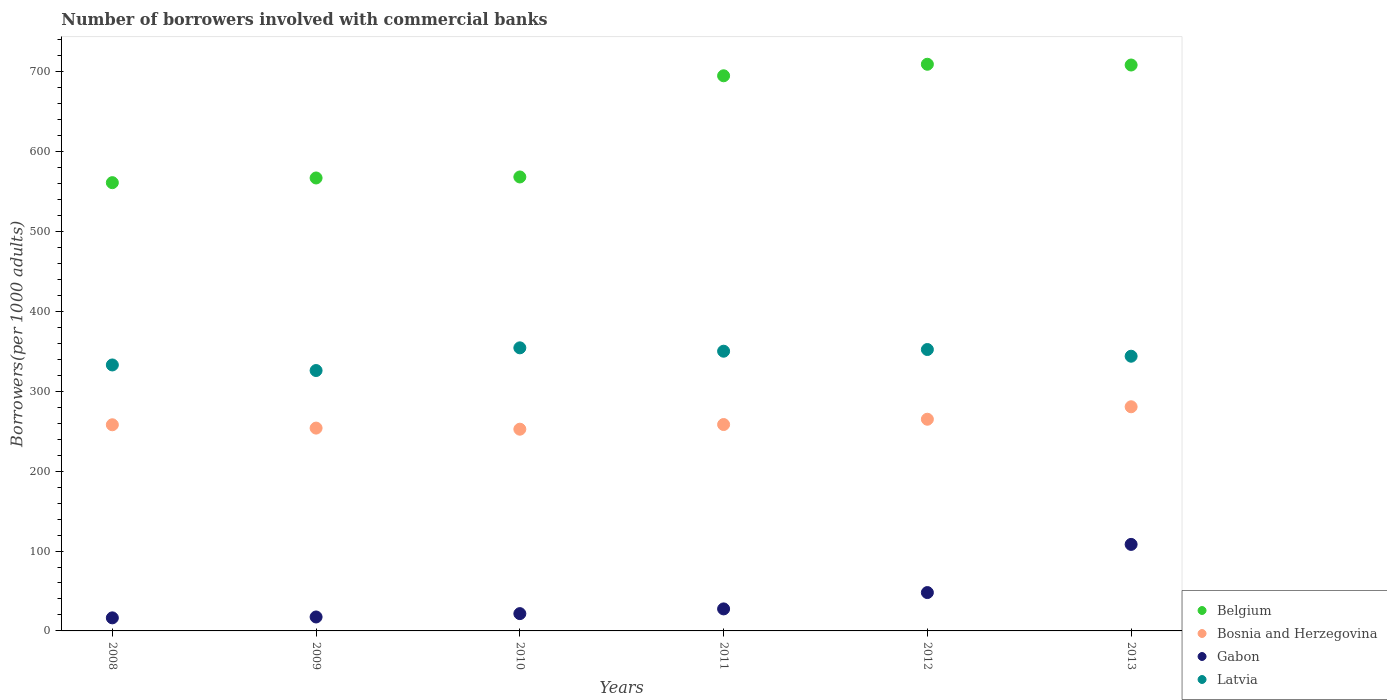What is the number of borrowers involved with commercial banks in Bosnia and Herzegovina in 2011?
Your response must be concise. 258.35. Across all years, what is the maximum number of borrowers involved with commercial banks in Bosnia and Herzegovina?
Make the answer very short. 280.59. Across all years, what is the minimum number of borrowers involved with commercial banks in Belgium?
Your answer should be very brief. 561.13. What is the total number of borrowers involved with commercial banks in Belgium in the graph?
Keep it short and to the point. 3809.04. What is the difference between the number of borrowers involved with commercial banks in Belgium in 2009 and that in 2011?
Your answer should be compact. -127.92. What is the difference between the number of borrowers involved with commercial banks in Bosnia and Herzegovina in 2008 and the number of borrowers involved with commercial banks in Latvia in 2009?
Keep it short and to the point. -67.89. What is the average number of borrowers involved with commercial banks in Latvia per year?
Keep it short and to the point. 343.25. In the year 2009, what is the difference between the number of borrowers involved with commercial banks in Bosnia and Herzegovina and number of borrowers involved with commercial banks in Belgium?
Your answer should be compact. -313.11. In how many years, is the number of borrowers involved with commercial banks in Latvia greater than 220?
Ensure brevity in your answer.  6. What is the ratio of the number of borrowers involved with commercial banks in Bosnia and Herzegovina in 2012 to that in 2013?
Ensure brevity in your answer.  0.94. Is the number of borrowers involved with commercial banks in Gabon in 2011 less than that in 2013?
Your answer should be compact. Yes. What is the difference between the highest and the second highest number of borrowers involved with commercial banks in Belgium?
Keep it short and to the point. 0.95. What is the difference between the highest and the lowest number of borrowers involved with commercial banks in Belgium?
Ensure brevity in your answer.  148.22. Is it the case that in every year, the sum of the number of borrowers involved with commercial banks in Gabon and number of borrowers involved with commercial banks in Latvia  is greater than the sum of number of borrowers involved with commercial banks in Bosnia and Herzegovina and number of borrowers involved with commercial banks in Belgium?
Your response must be concise. No. Is it the case that in every year, the sum of the number of borrowers involved with commercial banks in Belgium and number of borrowers involved with commercial banks in Gabon  is greater than the number of borrowers involved with commercial banks in Latvia?
Provide a succinct answer. Yes. Is the number of borrowers involved with commercial banks in Bosnia and Herzegovina strictly less than the number of borrowers involved with commercial banks in Gabon over the years?
Your response must be concise. No. Where does the legend appear in the graph?
Provide a succinct answer. Bottom right. How are the legend labels stacked?
Ensure brevity in your answer.  Vertical. What is the title of the graph?
Provide a short and direct response. Number of borrowers involved with commercial banks. Does "Europe(all income levels)" appear as one of the legend labels in the graph?
Offer a very short reply. No. What is the label or title of the X-axis?
Ensure brevity in your answer.  Years. What is the label or title of the Y-axis?
Offer a terse response. Borrowers(per 1000 adults). What is the Borrowers(per 1000 adults) in Belgium in 2008?
Make the answer very short. 561.13. What is the Borrowers(per 1000 adults) of Bosnia and Herzegovina in 2008?
Make the answer very short. 258.06. What is the Borrowers(per 1000 adults) in Gabon in 2008?
Your response must be concise. 16.35. What is the Borrowers(per 1000 adults) of Latvia in 2008?
Your response must be concise. 332.93. What is the Borrowers(per 1000 adults) in Belgium in 2009?
Offer a very short reply. 567. What is the Borrowers(per 1000 adults) of Bosnia and Herzegovina in 2009?
Your answer should be very brief. 253.89. What is the Borrowers(per 1000 adults) in Gabon in 2009?
Provide a succinct answer. 17.46. What is the Borrowers(per 1000 adults) in Latvia in 2009?
Your answer should be very brief. 325.95. What is the Borrowers(per 1000 adults) in Belgium in 2010?
Make the answer very short. 568.25. What is the Borrowers(per 1000 adults) of Bosnia and Herzegovina in 2010?
Ensure brevity in your answer.  252.52. What is the Borrowers(per 1000 adults) of Gabon in 2010?
Keep it short and to the point. 21.66. What is the Borrowers(per 1000 adults) in Latvia in 2010?
Offer a terse response. 354.36. What is the Borrowers(per 1000 adults) of Belgium in 2011?
Ensure brevity in your answer.  694.92. What is the Borrowers(per 1000 adults) in Bosnia and Herzegovina in 2011?
Offer a very short reply. 258.35. What is the Borrowers(per 1000 adults) in Gabon in 2011?
Make the answer very short. 27.56. What is the Borrowers(per 1000 adults) in Latvia in 2011?
Your response must be concise. 350.14. What is the Borrowers(per 1000 adults) in Belgium in 2012?
Give a very brief answer. 709.35. What is the Borrowers(per 1000 adults) of Bosnia and Herzegovina in 2012?
Ensure brevity in your answer.  264.98. What is the Borrowers(per 1000 adults) in Gabon in 2012?
Your response must be concise. 48.02. What is the Borrowers(per 1000 adults) of Latvia in 2012?
Keep it short and to the point. 352.26. What is the Borrowers(per 1000 adults) of Belgium in 2013?
Your answer should be very brief. 708.39. What is the Borrowers(per 1000 adults) in Bosnia and Herzegovina in 2013?
Give a very brief answer. 280.59. What is the Borrowers(per 1000 adults) in Gabon in 2013?
Provide a succinct answer. 108.3. What is the Borrowers(per 1000 adults) of Latvia in 2013?
Your answer should be compact. 343.87. Across all years, what is the maximum Borrowers(per 1000 adults) in Belgium?
Ensure brevity in your answer.  709.35. Across all years, what is the maximum Borrowers(per 1000 adults) in Bosnia and Herzegovina?
Offer a very short reply. 280.59. Across all years, what is the maximum Borrowers(per 1000 adults) in Gabon?
Offer a very short reply. 108.3. Across all years, what is the maximum Borrowers(per 1000 adults) of Latvia?
Keep it short and to the point. 354.36. Across all years, what is the minimum Borrowers(per 1000 adults) in Belgium?
Offer a very short reply. 561.13. Across all years, what is the minimum Borrowers(per 1000 adults) of Bosnia and Herzegovina?
Your answer should be compact. 252.52. Across all years, what is the minimum Borrowers(per 1000 adults) of Gabon?
Provide a short and direct response. 16.35. Across all years, what is the minimum Borrowers(per 1000 adults) of Latvia?
Keep it short and to the point. 325.95. What is the total Borrowers(per 1000 adults) in Belgium in the graph?
Give a very brief answer. 3809.04. What is the total Borrowers(per 1000 adults) of Bosnia and Herzegovina in the graph?
Your answer should be compact. 1568.4. What is the total Borrowers(per 1000 adults) in Gabon in the graph?
Keep it short and to the point. 239.34. What is the total Borrowers(per 1000 adults) in Latvia in the graph?
Make the answer very short. 2059.51. What is the difference between the Borrowers(per 1000 adults) of Belgium in 2008 and that in 2009?
Provide a short and direct response. -5.87. What is the difference between the Borrowers(per 1000 adults) in Bosnia and Herzegovina in 2008 and that in 2009?
Your answer should be very brief. 4.17. What is the difference between the Borrowers(per 1000 adults) of Gabon in 2008 and that in 2009?
Your answer should be compact. -1.11. What is the difference between the Borrowers(per 1000 adults) in Latvia in 2008 and that in 2009?
Provide a succinct answer. 6.98. What is the difference between the Borrowers(per 1000 adults) in Belgium in 2008 and that in 2010?
Your answer should be compact. -7.13. What is the difference between the Borrowers(per 1000 adults) of Bosnia and Herzegovina in 2008 and that in 2010?
Offer a very short reply. 5.55. What is the difference between the Borrowers(per 1000 adults) in Gabon in 2008 and that in 2010?
Offer a very short reply. -5.3. What is the difference between the Borrowers(per 1000 adults) in Latvia in 2008 and that in 2010?
Provide a short and direct response. -21.43. What is the difference between the Borrowers(per 1000 adults) of Belgium in 2008 and that in 2011?
Make the answer very short. -133.79. What is the difference between the Borrowers(per 1000 adults) in Bosnia and Herzegovina in 2008 and that in 2011?
Your answer should be very brief. -0.29. What is the difference between the Borrowers(per 1000 adults) of Gabon in 2008 and that in 2011?
Your answer should be compact. -11.21. What is the difference between the Borrowers(per 1000 adults) in Latvia in 2008 and that in 2011?
Make the answer very short. -17.21. What is the difference between the Borrowers(per 1000 adults) in Belgium in 2008 and that in 2012?
Your answer should be very brief. -148.22. What is the difference between the Borrowers(per 1000 adults) in Bosnia and Herzegovina in 2008 and that in 2012?
Your response must be concise. -6.92. What is the difference between the Borrowers(per 1000 adults) in Gabon in 2008 and that in 2012?
Offer a terse response. -31.67. What is the difference between the Borrowers(per 1000 adults) in Latvia in 2008 and that in 2012?
Offer a terse response. -19.32. What is the difference between the Borrowers(per 1000 adults) of Belgium in 2008 and that in 2013?
Provide a succinct answer. -147.27. What is the difference between the Borrowers(per 1000 adults) of Bosnia and Herzegovina in 2008 and that in 2013?
Your answer should be compact. -22.52. What is the difference between the Borrowers(per 1000 adults) of Gabon in 2008 and that in 2013?
Your answer should be very brief. -91.95. What is the difference between the Borrowers(per 1000 adults) of Latvia in 2008 and that in 2013?
Give a very brief answer. -10.93. What is the difference between the Borrowers(per 1000 adults) in Belgium in 2009 and that in 2010?
Keep it short and to the point. -1.25. What is the difference between the Borrowers(per 1000 adults) of Bosnia and Herzegovina in 2009 and that in 2010?
Your answer should be very brief. 1.38. What is the difference between the Borrowers(per 1000 adults) of Gabon in 2009 and that in 2010?
Provide a succinct answer. -4.2. What is the difference between the Borrowers(per 1000 adults) of Latvia in 2009 and that in 2010?
Offer a very short reply. -28.41. What is the difference between the Borrowers(per 1000 adults) in Belgium in 2009 and that in 2011?
Provide a short and direct response. -127.92. What is the difference between the Borrowers(per 1000 adults) in Bosnia and Herzegovina in 2009 and that in 2011?
Your answer should be very brief. -4.46. What is the difference between the Borrowers(per 1000 adults) of Gabon in 2009 and that in 2011?
Your answer should be very brief. -10.1. What is the difference between the Borrowers(per 1000 adults) of Latvia in 2009 and that in 2011?
Provide a short and direct response. -24.19. What is the difference between the Borrowers(per 1000 adults) of Belgium in 2009 and that in 2012?
Your answer should be very brief. -142.35. What is the difference between the Borrowers(per 1000 adults) of Bosnia and Herzegovina in 2009 and that in 2012?
Ensure brevity in your answer.  -11.09. What is the difference between the Borrowers(per 1000 adults) in Gabon in 2009 and that in 2012?
Ensure brevity in your answer.  -30.56. What is the difference between the Borrowers(per 1000 adults) in Latvia in 2009 and that in 2012?
Provide a short and direct response. -26.3. What is the difference between the Borrowers(per 1000 adults) of Belgium in 2009 and that in 2013?
Your response must be concise. -141.39. What is the difference between the Borrowers(per 1000 adults) in Bosnia and Herzegovina in 2009 and that in 2013?
Ensure brevity in your answer.  -26.69. What is the difference between the Borrowers(per 1000 adults) in Gabon in 2009 and that in 2013?
Your answer should be compact. -90.84. What is the difference between the Borrowers(per 1000 adults) of Latvia in 2009 and that in 2013?
Provide a succinct answer. -17.92. What is the difference between the Borrowers(per 1000 adults) in Belgium in 2010 and that in 2011?
Give a very brief answer. -126.66. What is the difference between the Borrowers(per 1000 adults) in Bosnia and Herzegovina in 2010 and that in 2011?
Make the answer very short. -5.84. What is the difference between the Borrowers(per 1000 adults) of Gabon in 2010 and that in 2011?
Give a very brief answer. -5.9. What is the difference between the Borrowers(per 1000 adults) in Latvia in 2010 and that in 2011?
Your answer should be very brief. 4.22. What is the difference between the Borrowers(per 1000 adults) of Belgium in 2010 and that in 2012?
Your answer should be compact. -141.09. What is the difference between the Borrowers(per 1000 adults) in Bosnia and Herzegovina in 2010 and that in 2012?
Ensure brevity in your answer.  -12.47. What is the difference between the Borrowers(per 1000 adults) of Gabon in 2010 and that in 2012?
Make the answer very short. -26.36. What is the difference between the Borrowers(per 1000 adults) in Latvia in 2010 and that in 2012?
Your response must be concise. 2.11. What is the difference between the Borrowers(per 1000 adults) of Belgium in 2010 and that in 2013?
Provide a short and direct response. -140.14. What is the difference between the Borrowers(per 1000 adults) in Bosnia and Herzegovina in 2010 and that in 2013?
Your answer should be very brief. -28.07. What is the difference between the Borrowers(per 1000 adults) in Gabon in 2010 and that in 2013?
Offer a very short reply. -86.65. What is the difference between the Borrowers(per 1000 adults) in Latvia in 2010 and that in 2013?
Your response must be concise. 10.49. What is the difference between the Borrowers(per 1000 adults) in Belgium in 2011 and that in 2012?
Give a very brief answer. -14.43. What is the difference between the Borrowers(per 1000 adults) of Bosnia and Herzegovina in 2011 and that in 2012?
Offer a terse response. -6.63. What is the difference between the Borrowers(per 1000 adults) in Gabon in 2011 and that in 2012?
Your answer should be compact. -20.46. What is the difference between the Borrowers(per 1000 adults) of Latvia in 2011 and that in 2012?
Your response must be concise. -2.12. What is the difference between the Borrowers(per 1000 adults) in Belgium in 2011 and that in 2013?
Provide a short and direct response. -13.48. What is the difference between the Borrowers(per 1000 adults) in Bosnia and Herzegovina in 2011 and that in 2013?
Your answer should be compact. -22.23. What is the difference between the Borrowers(per 1000 adults) in Gabon in 2011 and that in 2013?
Keep it short and to the point. -80.74. What is the difference between the Borrowers(per 1000 adults) of Latvia in 2011 and that in 2013?
Your answer should be compact. 6.27. What is the difference between the Borrowers(per 1000 adults) of Belgium in 2012 and that in 2013?
Make the answer very short. 0.95. What is the difference between the Borrowers(per 1000 adults) in Bosnia and Herzegovina in 2012 and that in 2013?
Offer a terse response. -15.6. What is the difference between the Borrowers(per 1000 adults) of Gabon in 2012 and that in 2013?
Provide a short and direct response. -60.28. What is the difference between the Borrowers(per 1000 adults) in Latvia in 2012 and that in 2013?
Ensure brevity in your answer.  8.39. What is the difference between the Borrowers(per 1000 adults) in Belgium in 2008 and the Borrowers(per 1000 adults) in Bosnia and Herzegovina in 2009?
Offer a terse response. 307.23. What is the difference between the Borrowers(per 1000 adults) in Belgium in 2008 and the Borrowers(per 1000 adults) in Gabon in 2009?
Your answer should be very brief. 543.67. What is the difference between the Borrowers(per 1000 adults) in Belgium in 2008 and the Borrowers(per 1000 adults) in Latvia in 2009?
Your answer should be very brief. 235.17. What is the difference between the Borrowers(per 1000 adults) of Bosnia and Herzegovina in 2008 and the Borrowers(per 1000 adults) of Gabon in 2009?
Your answer should be very brief. 240.61. What is the difference between the Borrowers(per 1000 adults) of Bosnia and Herzegovina in 2008 and the Borrowers(per 1000 adults) of Latvia in 2009?
Ensure brevity in your answer.  -67.89. What is the difference between the Borrowers(per 1000 adults) of Gabon in 2008 and the Borrowers(per 1000 adults) of Latvia in 2009?
Give a very brief answer. -309.6. What is the difference between the Borrowers(per 1000 adults) of Belgium in 2008 and the Borrowers(per 1000 adults) of Bosnia and Herzegovina in 2010?
Your response must be concise. 308.61. What is the difference between the Borrowers(per 1000 adults) in Belgium in 2008 and the Borrowers(per 1000 adults) in Gabon in 2010?
Ensure brevity in your answer.  539.47. What is the difference between the Borrowers(per 1000 adults) in Belgium in 2008 and the Borrowers(per 1000 adults) in Latvia in 2010?
Give a very brief answer. 206.76. What is the difference between the Borrowers(per 1000 adults) of Bosnia and Herzegovina in 2008 and the Borrowers(per 1000 adults) of Gabon in 2010?
Give a very brief answer. 236.41. What is the difference between the Borrowers(per 1000 adults) of Bosnia and Herzegovina in 2008 and the Borrowers(per 1000 adults) of Latvia in 2010?
Keep it short and to the point. -96.3. What is the difference between the Borrowers(per 1000 adults) in Gabon in 2008 and the Borrowers(per 1000 adults) in Latvia in 2010?
Your response must be concise. -338.01. What is the difference between the Borrowers(per 1000 adults) of Belgium in 2008 and the Borrowers(per 1000 adults) of Bosnia and Herzegovina in 2011?
Give a very brief answer. 302.77. What is the difference between the Borrowers(per 1000 adults) of Belgium in 2008 and the Borrowers(per 1000 adults) of Gabon in 2011?
Offer a very short reply. 533.57. What is the difference between the Borrowers(per 1000 adults) in Belgium in 2008 and the Borrowers(per 1000 adults) in Latvia in 2011?
Ensure brevity in your answer.  210.99. What is the difference between the Borrowers(per 1000 adults) in Bosnia and Herzegovina in 2008 and the Borrowers(per 1000 adults) in Gabon in 2011?
Provide a succinct answer. 230.5. What is the difference between the Borrowers(per 1000 adults) in Bosnia and Herzegovina in 2008 and the Borrowers(per 1000 adults) in Latvia in 2011?
Offer a very short reply. -92.08. What is the difference between the Borrowers(per 1000 adults) in Gabon in 2008 and the Borrowers(per 1000 adults) in Latvia in 2011?
Keep it short and to the point. -333.79. What is the difference between the Borrowers(per 1000 adults) of Belgium in 2008 and the Borrowers(per 1000 adults) of Bosnia and Herzegovina in 2012?
Provide a short and direct response. 296.14. What is the difference between the Borrowers(per 1000 adults) in Belgium in 2008 and the Borrowers(per 1000 adults) in Gabon in 2012?
Offer a very short reply. 513.11. What is the difference between the Borrowers(per 1000 adults) in Belgium in 2008 and the Borrowers(per 1000 adults) in Latvia in 2012?
Give a very brief answer. 208.87. What is the difference between the Borrowers(per 1000 adults) of Bosnia and Herzegovina in 2008 and the Borrowers(per 1000 adults) of Gabon in 2012?
Provide a short and direct response. 210.05. What is the difference between the Borrowers(per 1000 adults) of Bosnia and Herzegovina in 2008 and the Borrowers(per 1000 adults) of Latvia in 2012?
Your answer should be compact. -94.19. What is the difference between the Borrowers(per 1000 adults) of Gabon in 2008 and the Borrowers(per 1000 adults) of Latvia in 2012?
Your response must be concise. -335.9. What is the difference between the Borrowers(per 1000 adults) of Belgium in 2008 and the Borrowers(per 1000 adults) of Bosnia and Herzegovina in 2013?
Your response must be concise. 280.54. What is the difference between the Borrowers(per 1000 adults) in Belgium in 2008 and the Borrowers(per 1000 adults) in Gabon in 2013?
Your answer should be very brief. 452.83. What is the difference between the Borrowers(per 1000 adults) in Belgium in 2008 and the Borrowers(per 1000 adults) in Latvia in 2013?
Your answer should be compact. 217.26. What is the difference between the Borrowers(per 1000 adults) of Bosnia and Herzegovina in 2008 and the Borrowers(per 1000 adults) of Gabon in 2013?
Offer a very short reply. 149.76. What is the difference between the Borrowers(per 1000 adults) of Bosnia and Herzegovina in 2008 and the Borrowers(per 1000 adults) of Latvia in 2013?
Ensure brevity in your answer.  -85.8. What is the difference between the Borrowers(per 1000 adults) of Gabon in 2008 and the Borrowers(per 1000 adults) of Latvia in 2013?
Give a very brief answer. -327.52. What is the difference between the Borrowers(per 1000 adults) of Belgium in 2009 and the Borrowers(per 1000 adults) of Bosnia and Herzegovina in 2010?
Ensure brevity in your answer.  314.48. What is the difference between the Borrowers(per 1000 adults) in Belgium in 2009 and the Borrowers(per 1000 adults) in Gabon in 2010?
Your answer should be very brief. 545.34. What is the difference between the Borrowers(per 1000 adults) in Belgium in 2009 and the Borrowers(per 1000 adults) in Latvia in 2010?
Your answer should be compact. 212.64. What is the difference between the Borrowers(per 1000 adults) in Bosnia and Herzegovina in 2009 and the Borrowers(per 1000 adults) in Gabon in 2010?
Provide a succinct answer. 232.24. What is the difference between the Borrowers(per 1000 adults) of Bosnia and Herzegovina in 2009 and the Borrowers(per 1000 adults) of Latvia in 2010?
Give a very brief answer. -100.47. What is the difference between the Borrowers(per 1000 adults) of Gabon in 2009 and the Borrowers(per 1000 adults) of Latvia in 2010?
Offer a very short reply. -336.91. What is the difference between the Borrowers(per 1000 adults) in Belgium in 2009 and the Borrowers(per 1000 adults) in Bosnia and Herzegovina in 2011?
Keep it short and to the point. 308.65. What is the difference between the Borrowers(per 1000 adults) of Belgium in 2009 and the Borrowers(per 1000 adults) of Gabon in 2011?
Provide a succinct answer. 539.44. What is the difference between the Borrowers(per 1000 adults) in Belgium in 2009 and the Borrowers(per 1000 adults) in Latvia in 2011?
Offer a very short reply. 216.86. What is the difference between the Borrowers(per 1000 adults) in Bosnia and Herzegovina in 2009 and the Borrowers(per 1000 adults) in Gabon in 2011?
Give a very brief answer. 226.33. What is the difference between the Borrowers(per 1000 adults) of Bosnia and Herzegovina in 2009 and the Borrowers(per 1000 adults) of Latvia in 2011?
Keep it short and to the point. -96.25. What is the difference between the Borrowers(per 1000 adults) of Gabon in 2009 and the Borrowers(per 1000 adults) of Latvia in 2011?
Ensure brevity in your answer.  -332.68. What is the difference between the Borrowers(per 1000 adults) of Belgium in 2009 and the Borrowers(per 1000 adults) of Bosnia and Herzegovina in 2012?
Provide a short and direct response. 302.02. What is the difference between the Borrowers(per 1000 adults) in Belgium in 2009 and the Borrowers(per 1000 adults) in Gabon in 2012?
Offer a terse response. 518.98. What is the difference between the Borrowers(per 1000 adults) in Belgium in 2009 and the Borrowers(per 1000 adults) in Latvia in 2012?
Offer a very short reply. 214.74. What is the difference between the Borrowers(per 1000 adults) of Bosnia and Herzegovina in 2009 and the Borrowers(per 1000 adults) of Gabon in 2012?
Ensure brevity in your answer.  205.88. What is the difference between the Borrowers(per 1000 adults) in Bosnia and Herzegovina in 2009 and the Borrowers(per 1000 adults) in Latvia in 2012?
Ensure brevity in your answer.  -98.36. What is the difference between the Borrowers(per 1000 adults) of Gabon in 2009 and the Borrowers(per 1000 adults) of Latvia in 2012?
Provide a short and direct response. -334.8. What is the difference between the Borrowers(per 1000 adults) of Belgium in 2009 and the Borrowers(per 1000 adults) of Bosnia and Herzegovina in 2013?
Provide a short and direct response. 286.41. What is the difference between the Borrowers(per 1000 adults) of Belgium in 2009 and the Borrowers(per 1000 adults) of Gabon in 2013?
Keep it short and to the point. 458.7. What is the difference between the Borrowers(per 1000 adults) in Belgium in 2009 and the Borrowers(per 1000 adults) in Latvia in 2013?
Ensure brevity in your answer.  223.13. What is the difference between the Borrowers(per 1000 adults) in Bosnia and Herzegovina in 2009 and the Borrowers(per 1000 adults) in Gabon in 2013?
Make the answer very short. 145.59. What is the difference between the Borrowers(per 1000 adults) in Bosnia and Herzegovina in 2009 and the Borrowers(per 1000 adults) in Latvia in 2013?
Your answer should be very brief. -89.98. What is the difference between the Borrowers(per 1000 adults) of Gabon in 2009 and the Borrowers(per 1000 adults) of Latvia in 2013?
Your answer should be very brief. -326.41. What is the difference between the Borrowers(per 1000 adults) of Belgium in 2010 and the Borrowers(per 1000 adults) of Bosnia and Herzegovina in 2011?
Make the answer very short. 309.9. What is the difference between the Borrowers(per 1000 adults) of Belgium in 2010 and the Borrowers(per 1000 adults) of Gabon in 2011?
Ensure brevity in your answer.  540.69. What is the difference between the Borrowers(per 1000 adults) in Belgium in 2010 and the Borrowers(per 1000 adults) in Latvia in 2011?
Offer a terse response. 218.12. What is the difference between the Borrowers(per 1000 adults) of Bosnia and Herzegovina in 2010 and the Borrowers(per 1000 adults) of Gabon in 2011?
Keep it short and to the point. 224.96. What is the difference between the Borrowers(per 1000 adults) in Bosnia and Herzegovina in 2010 and the Borrowers(per 1000 adults) in Latvia in 2011?
Keep it short and to the point. -97.62. What is the difference between the Borrowers(per 1000 adults) in Gabon in 2010 and the Borrowers(per 1000 adults) in Latvia in 2011?
Keep it short and to the point. -328.48. What is the difference between the Borrowers(per 1000 adults) of Belgium in 2010 and the Borrowers(per 1000 adults) of Bosnia and Herzegovina in 2012?
Offer a terse response. 303.27. What is the difference between the Borrowers(per 1000 adults) in Belgium in 2010 and the Borrowers(per 1000 adults) in Gabon in 2012?
Make the answer very short. 520.24. What is the difference between the Borrowers(per 1000 adults) of Belgium in 2010 and the Borrowers(per 1000 adults) of Latvia in 2012?
Provide a short and direct response. 216. What is the difference between the Borrowers(per 1000 adults) in Bosnia and Herzegovina in 2010 and the Borrowers(per 1000 adults) in Gabon in 2012?
Provide a succinct answer. 204.5. What is the difference between the Borrowers(per 1000 adults) in Bosnia and Herzegovina in 2010 and the Borrowers(per 1000 adults) in Latvia in 2012?
Offer a terse response. -99.74. What is the difference between the Borrowers(per 1000 adults) in Gabon in 2010 and the Borrowers(per 1000 adults) in Latvia in 2012?
Your answer should be very brief. -330.6. What is the difference between the Borrowers(per 1000 adults) of Belgium in 2010 and the Borrowers(per 1000 adults) of Bosnia and Herzegovina in 2013?
Your answer should be very brief. 287.67. What is the difference between the Borrowers(per 1000 adults) in Belgium in 2010 and the Borrowers(per 1000 adults) in Gabon in 2013?
Give a very brief answer. 459.95. What is the difference between the Borrowers(per 1000 adults) of Belgium in 2010 and the Borrowers(per 1000 adults) of Latvia in 2013?
Your answer should be very brief. 224.39. What is the difference between the Borrowers(per 1000 adults) in Bosnia and Herzegovina in 2010 and the Borrowers(per 1000 adults) in Gabon in 2013?
Provide a short and direct response. 144.22. What is the difference between the Borrowers(per 1000 adults) in Bosnia and Herzegovina in 2010 and the Borrowers(per 1000 adults) in Latvia in 2013?
Your answer should be compact. -91.35. What is the difference between the Borrowers(per 1000 adults) of Gabon in 2010 and the Borrowers(per 1000 adults) of Latvia in 2013?
Your answer should be compact. -322.21. What is the difference between the Borrowers(per 1000 adults) in Belgium in 2011 and the Borrowers(per 1000 adults) in Bosnia and Herzegovina in 2012?
Ensure brevity in your answer.  429.93. What is the difference between the Borrowers(per 1000 adults) of Belgium in 2011 and the Borrowers(per 1000 adults) of Gabon in 2012?
Provide a succinct answer. 646.9. What is the difference between the Borrowers(per 1000 adults) in Belgium in 2011 and the Borrowers(per 1000 adults) in Latvia in 2012?
Make the answer very short. 342.66. What is the difference between the Borrowers(per 1000 adults) of Bosnia and Herzegovina in 2011 and the Borrowers(per 1000 adults) of Gabon in 2012?
Make the answer very short. 210.34. What is the difference between the Borrowers(per 1000 adults) in Bosnia and Herzegovina in 2011 and the Borrowers(per 1000 adults) in Latvia in 2012?
Offer a terse response. -93.9. What is the difference between the Borrowers(per 1000 adults) in Gabon in 2011 and the Borrowers(per 1000 adults) in Latvia in 2012?
Offer a very short reply. -324.7. What is the difference between the Borrowers(per 1000 adults) of Belgium in 2011 and the Borrowers(per 1000 adults) of Bosnia and Herzegovina in 2013?
Provide a short and direct response. 414.33. What is the difference between the Borrowers(per 1000 adults) of Belgium in 2011 and the Borrowers(per 1000 adults) of Gabon in 2013?
Offer a very short reply. 586.61. What is the difference between the Borrowers(per 1000 adults) of Belgium in 2011 and the Borrowers(per 1000 adults) of Latvia in 2013?
Ensure brevity in your answer.  351.05. What is the difference between the Borrowers(per 1000 adults) of Bosnia and Herzegovina in 2011 and the Borrowers(per 1000 adults) of Gabon in 2013?
Your response must be concise. 150.05. What is the difference between the Borrowers(per 1000 adults) in Bosnia and Herzegovina in 2011 and the Borrowers(per 1000 adults) in Latvia in 2013?
Provide a succinct answer. -85.51. What is the difference between the Borrowers(per 1000 adults) in Gabon in 2011 and the Borrowers(per 1000 adults) in Latvia in 2013?
Your response must be concise. -316.31. What is the difference between the Borrowers(per 1000 adults) of Belgium in 2012 and the Borrowers(per 1000 adults) of Bosnia and Herzegovina in 2013?
Your answer should be compact. 428.76. What is the difference between the Borrowers(per 1000 adults) in Belgium in 2012 and the Borrowers(per 1000 adults) in Gabon in 2013?
Provide a succinct answer. 601.05. What is the difference between the Borrowers(per 1000 adults) of Belgium in 2012 and the Borrowers(per 1000 adults) of Latvia in 2013?
Your answer should be compact. 365.48. What is the difference between the Borrowers(per 1000 adults) of Bosnia and Herzegovina in 2012 and the Borrowers(per 1000 adults) of Gabon in 2013?
Ensure brevity in your answer.  156.68. What is the difference between the Borrowers(per 1000 adults) of Bosnia and Herzegovina in 2012 and the Borrowers(per 1000 adults) of Latvia in 2013?
Keep it short and to the point. -78.88. What is the difference between the Borrowers(per 1000 adults) of Gabon in 2012 and the Borrowers(per 1000 adults) of Latvia in 2013?
Your answer should be compact. -295.85. What is the average Borrowers(per 1000 adults) of Belgium per year?
Your answer should be very brief. 634.84. What is the average Borrowers(per 1000 adults) in Bosnia and Herzegovina per year?
Offer a terse response. 261.4. What is the average Borrowers(per 1000 adults) in Gabon per year?
Ensure brevity in your answer.  39.89. What is the average Borrowers(per 1000 adults) in Latvia per year?
Your answer should be very brief. 343.25. In the year 2008, what is the difference between the Borrowers(per 1000 adults) of Belgium and Borrowers(per 1000 adults) of Bosnia and Herzegovina?
Your response must be concise. 303.06. In the year 2008, what is the difference between the Borrowers(per 1000 adults) of Belgium and Borrowers(per 1000 adults) of Gabon?
Provide a succinct answer. 544.77. In the year 2008, what is the difference between the Borrowers(per 1000 adults) of Belgium and Borrowers(per 1000 adults) of Latvia?
Offer a terse response. 228.19. In the year 2008, what is the difference between the Borrowers(per 1000 adults) in Bosnia and Herzegovina and Borrowers(per 1000 adults) in Gabon?
Ensure brevity in your answer.  241.71. In the year 2008, what is the difference between the Borrowers(per 1000 adults) of Bosnia and Herzegovina and Borrowers(per 1000 adults) of Latvia?
Make the answer very short. -74.87. In the year 2008, what is the difference between the Borrowers(per 1000 adults) of Gabon and Borrowers(per 1000 adults) of Latvia?
Provide a succinct answer. -316.58. In the year 2009, what is the difference between the Borrowers(per 1000 adults) of Belgium and Borrowers(per 1000 adults) of Bosnia and Herzegovina?
Offer a terse response. 313.11. In the year 2009, what is the difference between the Borrowers(per 1000 adults) of Belgium and Borrowers(per 1000 adults) of Gabon?
Make the answer very short. 549.54. In the year 2009, what is the difference between the Borrowers(per 1000 adults) in Belgium and Borrowers(per 1000 adults) in Latvia?
Ensure brevity in your answer.  241.05. In the year 2009, what is the difference between the Borrowers(per 1000 adults) of Bosnia and Herzegovina and Borrowers(per 1000 adults) of Gabon?
Ensure brevity in your answer.  236.44. In the year 2009, what is the difference between the Borrowers(per 1000 adults) of Bosnia and Herzegovina and Borrowers(per 1000 adults) of Latvia?
Offer a very short reply. -72.06. In the year 2009, what is the difference between the Borrowers(per 1000 adults) of Gabon and Borrowers(per 1000 adults) of Latvia?
Your answer should be compact. -308.49. In the year 2010, what is the difference between the Borrowers(per 1000 adults) in Belgium and Borrowers(per 1000 adults) in Bosnia and Herzegovina?
Give a very brief answer. 315.74. In the year 2010, what is the difference between the Borrowers(per 1000 adults) of Belgium and Borrowers(per 1000 adults) of Gabon?
Your response must be concise. 546.6. In the year 2010, what is the difference between the Borrowers(per 1000 adults) of Belgium and Borrowers(per 1000 adults) of Latvia?
Your answer should be very brief. 213.89. In the year 2010, what is the difference between the Borrowers(per 1000 adults) in Bosnia and Herzegovina and Borrowers(per 1000 adults) in Gabon?
Provide a short and direct response. 230.86. In the year 2010, what is the difference between the Borrowers(per 1000 adults) of Bosnia and Herzegovina and Borrowers(per 1000 adults) of Latvia?
Keep it short and to the point. -101.85. In the year 2010, what is the difference between the Borrowers(per 1000 adults) in Gabon and Borrowers(per 1000 adults) in Latvia?
Your answer should be compact. -332.71. In the year 2011, what is the difference between the Borrowers(per 1000 adults) of Belgium and Borrowers(per 1000 adults) of Bosnia and Herzegovina?
Ensure brevity in your answer.  436.56. In the year 2011, what is the difference between the Borrowers(per 1000 adults) of Belgium and Borrowers(per 1000 adults) of Gabon?
Ensure brevity in your answer.  667.36. In the year 2011, what is the difference between the Borrowers(per 1000 adults) in Belgium and Borrowers(per 1000 adults) in Latvia?
Provide a succinct answer. 344.78. In the year 2011, what is the difference between the Borrowers(per 1000 adults) in Bosnia and Herzegovina and Borrowers(per 1000 adults) in Gabon?
Your answer should be very brief. 230.79. In the year 2011, what is the difference between the Borrowers(per 1000 adults) of Bosnia and Herzegovina and Borrowers(per 1000 adults) of Latvia?
Provide a short and direct response. -91.78. In the year 2011, what is the difference between the Borrowers(per 1000 adults) of Gabon and Borrowers(per 1000 adults) of Latvia?
Give a very brief answer. -322.58. In the year 2012, what is the difference between the Borrowers(per 1000 adults) of Belgium and Borrowers(per 1000 adults) of Bosnia and Herzegovina?
Provide a succinct answer. 444.36. In the year 2012, what is the difference between the Borrowers(per 1000 adults) in Belgium and Borrowers(per 1000 adults) in Gabon?
Provide a short and direct response. 661.33. In the year 2012, what is the difference between the Borrowers(per 1000 adults) in Belgium and Borrowers(per 1000 adults) in Latvia?
Your response must be concise. 357.09. In the year 2012, what is the difference between the Borrowers(per 1000 adults) in Bosnia and Herzegovina and Borrowers(per 1000 adults) in Gabon?
Provide a succinct answer. 216.97. In the year 2012, what is the difference between the Borrowers(per 1000 adults) of Bosnia and Herzegovina and Borrowers(per 1000 adults) of Latvia?
Keep it short and to the point. -87.27. In the year 2012, what is the difference between the Borrowers(per 1000 adults) in Gabon and Borrowers(per 1000 adults) in Latvia?
Provide a succinct answer. -304.24. In the year 2013, what is the difference between the Borrowers(per 1000 adults) in Belgium and Borrowers(per 1000 adults) in Bosnia and Herzegovina?
Keep it short and to the point. 427.81. In the year 2013, what is the difference between the Borrowers(per 1000 adults) in Belgium and Borrowers(per 1000 adults) in Gabon?
Your answer should be very brief. 600.09. In the year 2013, what is the difference between the Borrowers(per 1000 adults) in Belgium and Borrowers(per 1000 adults) in Latvia?
Give a very brief answer. 364.53. In the year 2013, what is the difference between the Borrowers(per 1000 adults) of Bosnia and Herzegovina and Borrowers(per 1000 adults) of Gabon?
Your answer should be very brief. 172.29. In the year 2013, what is the difference between the Borrowers(per 1000 adults) in Bosnia and Herzegovina and Borrowers(per 1000 adults) in Latvia?
Ensure brevity in your answer.  -63.28. In the year 2013, what is the difference between the Borrowers(per 1000 adults) in Gabon and Borrowers(per 1000 adults) in Latvia?
Offer a very short reply. -235.57. What is the ratio of the Borrowers(per 1000 adults) of Bosnia and Herzegovina in 2008 to that in 2009?
Provide a short and direct response. 1.02. What is the ratio of the Borrowers(per 1000 adults) of Gabon in 2008 to that in 2009?
Offer a very short reply. 0.94. What is the ratio of the Borrowers(per 1000 adults) in Latvia in 2008 to that in 2009?
Your response must be concise. 1.02. What is the ratio of the Borrowers(per 1000 adults) in Belgium in 2008 to that in 2010?
Your answer should be very brief. 0.99. What is the ratio of the Borrowers(per 1000 adults) of Gabon in 2008 to that in 2010?
Your response must be concise. 0.76. What is the ratio of the Borrowers(per 1000 adults) of Latvia in 2008 to that in 2010?
Your response must be concise. 0.94. What is the ratio of the Borrowers(per 1000 adults) in Belgium in 2008 to that in 2011?
Offer a terse response. 0.81. What is the ratio of the Borrowers(per 1000 adults) in Gabon in 2008 to that in 2011?
Ensure brevity in your answer.  0.59. What is the ratio of the Borrowers(per 1000 adults) in Latvia in 2008 to that in 2011?
Your answer should be compact. 0.95. What is the ratio of the Borrowers(per 1000 adults) in Belgium in 2008 to that in 2012?
Give a very brief answer. 0.79. What is the ratio of the Borrowers(per 1000 adults) in Bosnia and Herzegovina in 2008 to that in 2012?
Provide a short and direct response. 0.97. What is the ratio of the Borrowers(per 1000 adults) of Gabon in 2008 to that in 2012?
Offer a very short reply. 0.34. What is the ratio of the Borrowers(per 1000 adults) of Latvia in 2008 to that in 2012?
Provide a succinct answer. 0.95. What is the ratio of the Borrowers(per 1000 adults) of Belgium in 2008 to that in 2013?
Ensure brevity in your answer.  0.79. What is the ratio of the Borrowers(per 1000 adults) of Bosnia and Herzegovina in 2008 to that in 2013?
Ensure brevity in your answer.  0.92. What is the ratio of the Borrowers(per 1000 adults) in Gabon in 2008 to that in 2013?
Your answer should be very brief. 0.15. What is the ratio of the Borrowers(per 1000 adults) of Latvia in 2008 to that in 2013?
Give a very brief answer. 0.97. What is the ratio of the Borrowers(per 1000 adults) of Belgium in 2009 to that in 2010?
Offer a very short reply. 1. What is the ratio of the Borrowers(per 1000 adults) of Gabon in 2009 to that in 2010?
Offer a very short reply. 0.81. What is the ratio of the Borrowers(per 1000 adults) of Latvia in 2009 to that in 2010?
Make the answer very short. 0.92. What is the ratio of the Borrowers(per 1000 adults) of Belgium in 2009 to that in 2011?
Offer a terse response. 0.82. What is the ratio of the Borrowers(per 1000 adults) in Bosnia and Herzegovina in 2009 to that in 2011?
Your response must be concise. 0.98. What is the ratio of the Borrowers(per 1000 adults) of Gabon in 2009 to that in 2011?
Ensure brevity in your answer.  0.63. What is the ratio of the Borrowers(per 1000 adults) of Latvia in 2009 to that in 2011?
Offer a very short reply. 0.93. What is the ratio of the Borrowers(per 1000 adults) of Belgium in 2009 to that in 2012?
Keep it short and to the point. 0.8. What is the ratio of the Borrowers(per 1000 adults) of Bosnia and Herzegovina in 2009 to that in 2012?
Keep it short and to the point. 0.96. What is the ratio of the Borrowers(per 1000 adults) of Gabon in 2009 to that in 2012?
Offer a very short reply. 0.36. What is the ratio of the Borrowers(per 1000 adults) in Latvia in 2009 to that in 2012?
Your answer should be very brief. 0.93. What is the ratio of the Borrowers(per 1000 adults) of Belgium in 2009 to that in 2013?
Give a very brief answer. 0.8. What is the ratio of the Borrowers(per 1000 adults) in Bosnia and Herzegovina in 2009 to that in 2013?
Ensure brevity in your answer.  0.9. What is the ratio of the Borrowers(per 1000 adults) of Gabon in 2009 to that in 2013?
Give a very brief answer. 0.16. What is the ratio of the Borrowers(per 1000 adults) of Latvia in 2009 to that in 2013?
Your response must be concise. 0.95. What is the ratio of the Borrowers(per 1000 adults) of Belgium in 2010 to that in 2011?
Ensure brevity in your answer.  0.82. What is the ratio of the Borrowers(per 1000 adults) in Bosnia and Herzegovina in 2010 to that in 2011?
Your answer should be very brief. 0.98. What is the ratio of the Borrowers(per 1000 adults) of Gabon in 2010 to that in 2011?
Your answer should be compact. 0.79. What is the ratio of the Borrowers(per 1000 adults) of Latvia in 2010 to that in 2011?
Offer a very short reply. 1.01. What is the ratio of the Borrowers(per 1000 adults) of Belgium in 2010 to that in 2012?
Offer a terse response. 0.8. What is the ratio of the Borrowers(per 1000 adults) in Bosnia and Herzegovina in 2010 to that in 2012?
Give a very brief answer. 0.95. What is the ratio of the Borrowers(per 1000 adults) of Gabon in 2010 to that in 2012?
Your answer should be compact. 0.45. What is the ratio of the Borrowers(per 1000 adults) of Belgium in 2010 to that in 2013?
Your answer should be compact. 0.8. What is the ratio of the Borrowers(per 1000 adults) in Bosnia and Herzegovina in 2010 to that in 2013?
Your answer should be very brief. 0.9. What is the ratio of the Borrowers(per 1000 adults) of Gabon in 2010 to that in 2013?
Make the answer very short. 0.2. What is the ratio of the Borrowers(per 1000 adults) of Latvia in 2010 to that in 2013?
Offer a very short reply. 1.03. What is the ratio of the Borrowers(per 1000 adults) in Belgium in 2011 to that in 2012?
Make the answer very short. 0.98. What is the ratio of the Borrowers(per 1000 adults) in Bosnia and Herzegovina in 2011 to that in 2012?
Keep it short and to the point. 0.97. What is the ratio of the Borrowers(per 1000 adults) in Gabon in 2011 to that in 2012?
Make the answer very short. 0.57. What is the ratio of the Borrowers(per 1000 adults) in Belgium in 2011 to that in 2013?
Provide a short and direct response. 0.98. What is the ratio of the Borrowers(per 1000 adults) of Bosnia and Herzegovina in 2011 to that in 2013?
Provide a succinct answer. 0.92. What is the ratio of the Borrowers(per 1000 adults) of Gabon in 2011 to that in 2013?
Give a very brief answer. 0.25. What is the ratio of the Borrowers(per 1000 adults) in Latvia in 2011 to that in 2013?
Your answer should be compact. 1.02. What is the ratio of the Borrowers(per 1000 adults) in Belgium in 2012 to that in 2013?
Keep it short and to the point. 1. What is the ratio of the Borrowers(per 1000 adults) in Bosnia and Herzegovina in 2012 to that in 2013?
Provide a short and direct response. 0.94. What is the ratio of the Borrowers(per 1000 adults) in Gabon in 2012 to that in 2013?
Your answer should be compact. 0.44. What is the ratio of the Borrowers(per 1000 adults) in Latvia in 2012 to that in 2013?
Keep it short and to the point. 1.02. What is the difference between the highest and the second highest Borrowers(per 1000 adults) of Belgium?
Make the answer very short. 0.95. What is the difference between the highest and the second highest Borrowers(per 1000 adults) in Bosnia and Herzegovina?
Your answer should be compact. 15.6. What is the difference between the highest and the second highest Borrowers(per 1000 adults) of Gabon?
Give a very brief answer. 60.28. What is the difference between the highest and the second highest Borrowers(per 1000 adults) in Latvia?
Give a very brief answer. 2.11. What is the difference between the highest and the lowest Borrowers(per 1000 adults) of Belgium?
Provide a succinct answer. 148.22. What is the difference between the highest and the lowest Borrowers(per 1000 adults) of Bosnia and Herzegovina?
Your answer should be compact. 28.07. What is the difference between the highest and the lowest Borrowers(per 1000 adults) in Gabon?
Make the answer very short. 91.95. What is the difference between the highest and the lowest Borrowers(per 1000 adults) of Latvia?
Provide a succinct answer. 28.41. 